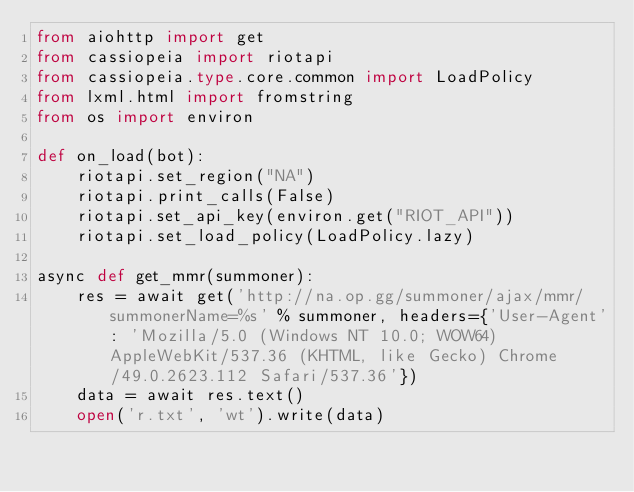<code> <loc_0><loc_0><loc_500><loc_500><_Python_>from aiohttp import get
from cassiopeia import riotapi
from cassiopeia.type.core.common import LoadPolicy
from lxml.html import fromstring
from os import environ

def on_load(bot):
    riotapi.set_region("NA")
    riotapi.print_calls(False)
    riotapi.set_api_key(environ.get("RIOT_API"))
    riotapi.set_load_policy(LoadPolicy.lazy)

async def get_mmr(summoner):
    res = await get('http://na.op.gg/summoner/ajax/mmr/summonerName=%s' % summoner, headers={'User-Agent': 'Mozilla/5.0 (Windows NT 10.0; WOW64) AppleWebKit/537.36 (KHTML, like Gecko) Chrome/49.0.2623.112 Safari/537.36'})
    data = await res.text()
    open('r.txt', 'wt').write(data)</code> 